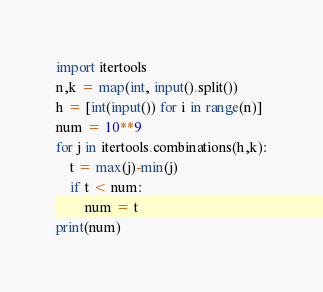Convert code to text. <code><loc_0><loc_0><loc_500><loc_500><_Python_>import itertools
n,k = map(int, input().split())
h = [int(input()) for i in range(n)]
num = 10**9
for j in itertools.combinations(h,k):
    t = max(j)-min(j)
    if t < num:
        num = t
print(num)</code> 